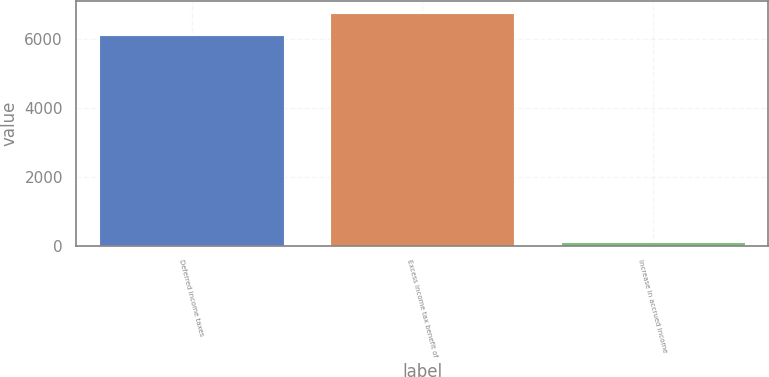<chart> <loc_0><loc_0><loc_500><loc_500><bar_chart><fcel>Deferred income taxes<fcel>Excess income tax benefit of<fcel>Increase in accrued income<nl><fcel>6101<fcel>6740.2<fcel>113<nl></chart> 